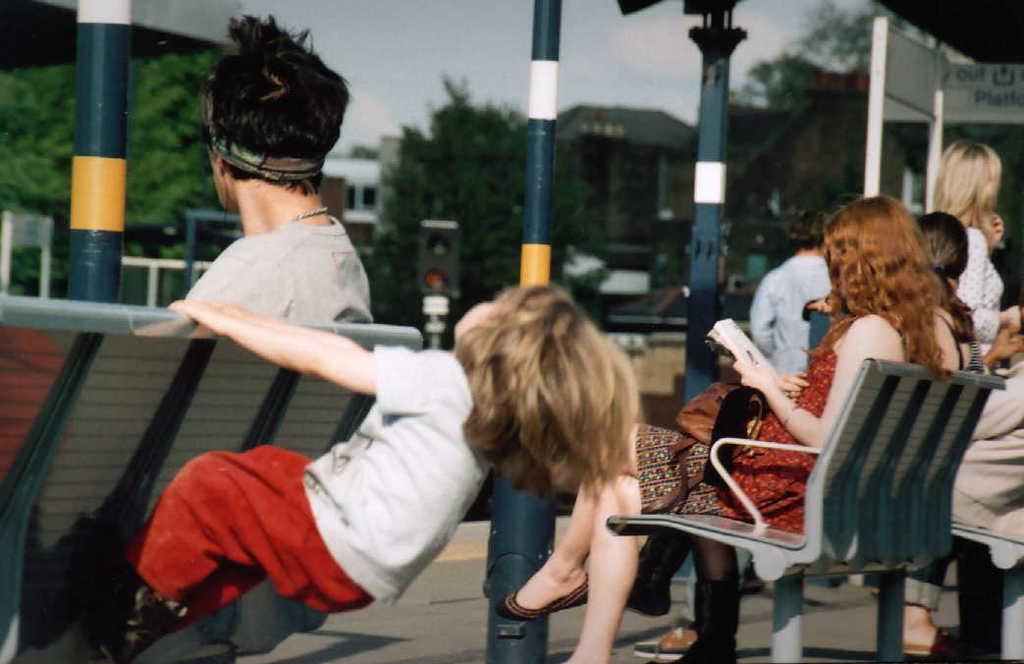Could you give a brief overview of what you see in this image? In this picture I can see few people are sitting on a chairs and watching, one girl is playing with chairs. 